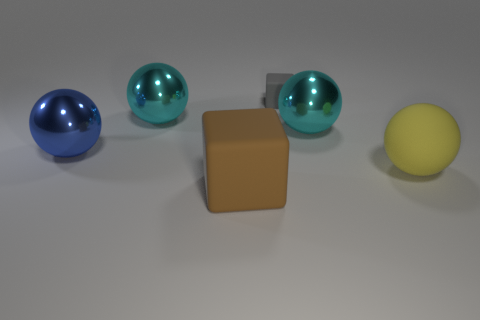Subtract all big matte balls. How many balls are left? 3 Subtract 1 spheres. How many spheres are left? 3 Subtract all cyan balls. How many balls are left? 2 Add 4 brown cubes. How many objects exist? 10 Subtract all balls. How many objects are left? 2 Add 4 big brown matte balls. How many big brown matte balls exist? 4 Subtract 1 gray blocks. How many objects are left? 5 Subtract all green balls. Subtract all brown cylinders. How many balls are left? 4 Subtract all gray cubes. How many blue balls are left? 1 Subtract all large rubber cubes. Subtract all blue objects. How many objects are left? 4 